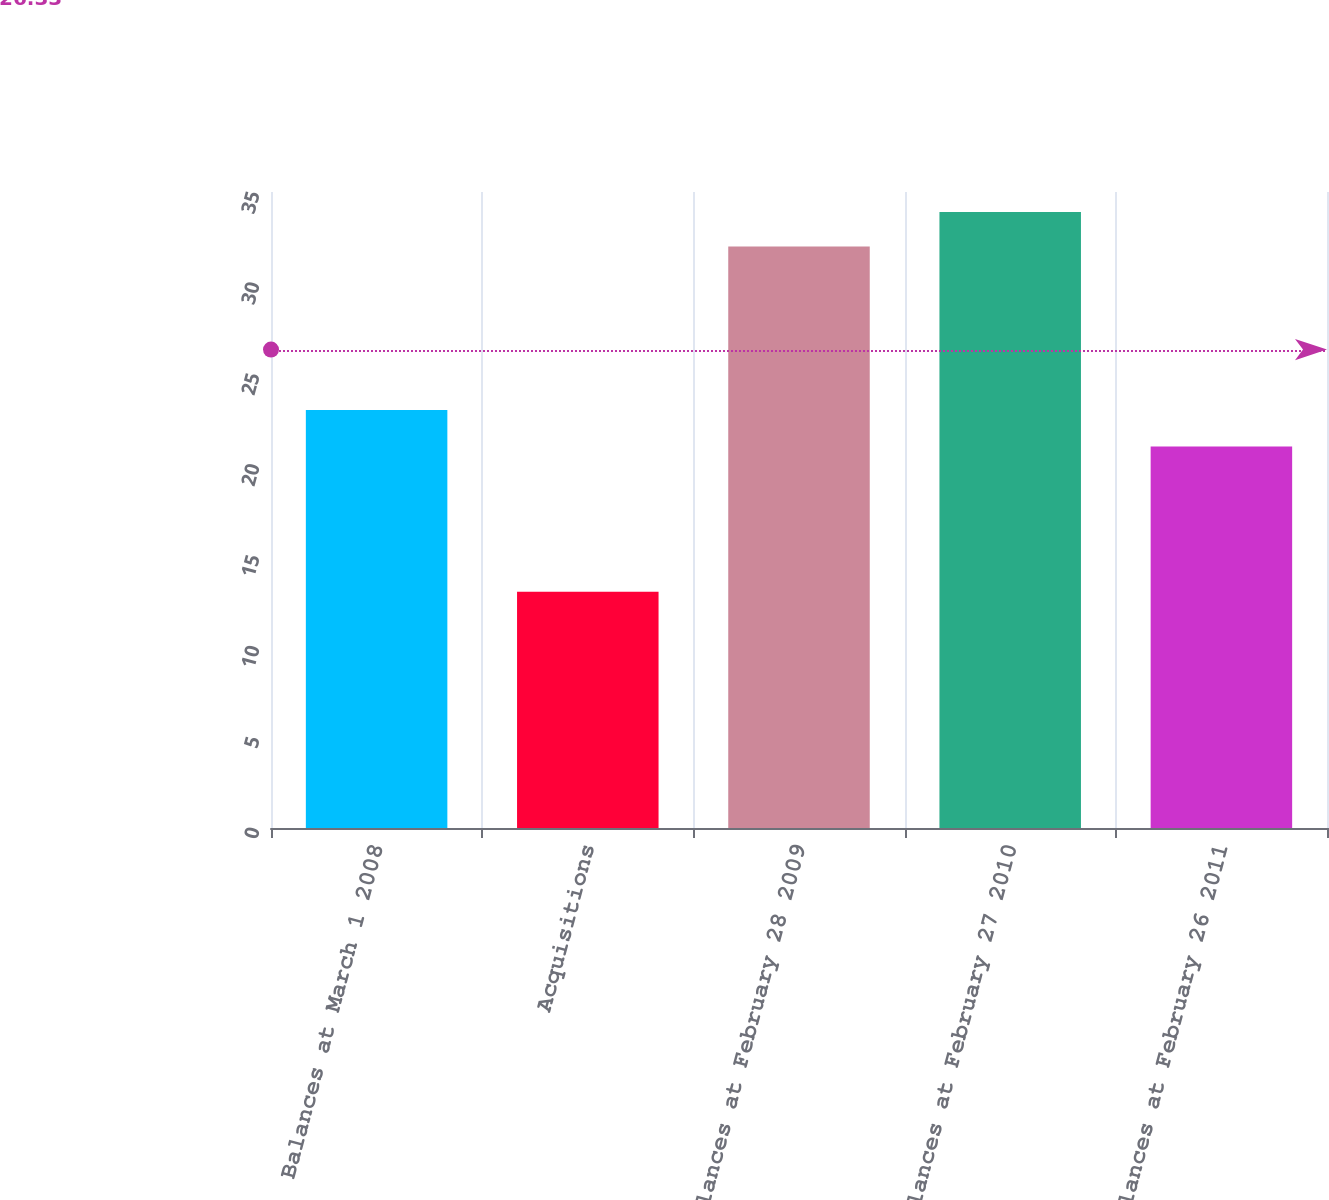<chart> <loc_0><loc_0><loc_500><loc_500><bar_chart><fcel>Balances at March 1 2008<fcel>Acquisitions<fcel>Balances at February 28 2009<fcel>Balances at February 27 2010<fcel>Balances at February 26 2011<nl><fcel>23<fcel>13<fcel>32<fcel>33.9<fcel>21<nl></chart> 